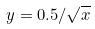Convert formula to latex. <formula><loc_0><loc_0><loc_500><loc_500>y = 0 . 5 / \sqrt { x }</formula> 